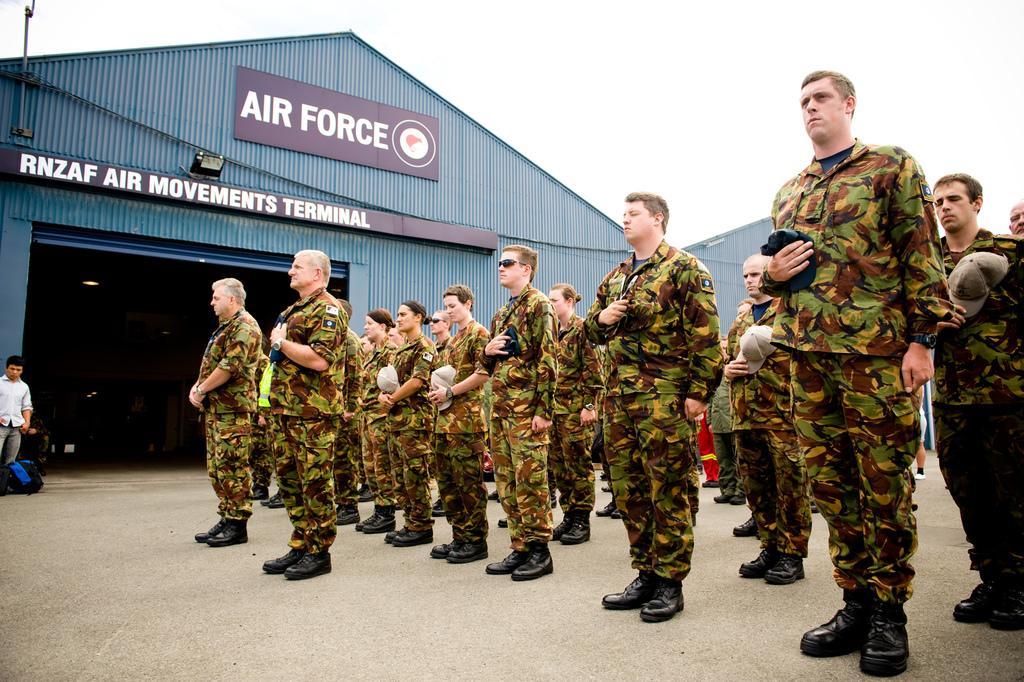Describe this image in one or two sentences. This picture is clicked outside. On the right we can see the group of persons wearing uniforms, holding some objects and standing on the ground. On the left there is a person standing on the ground and we can see there are some items and we can see the cabins and the text on the boards. In the background there is a sky and some other objects. 